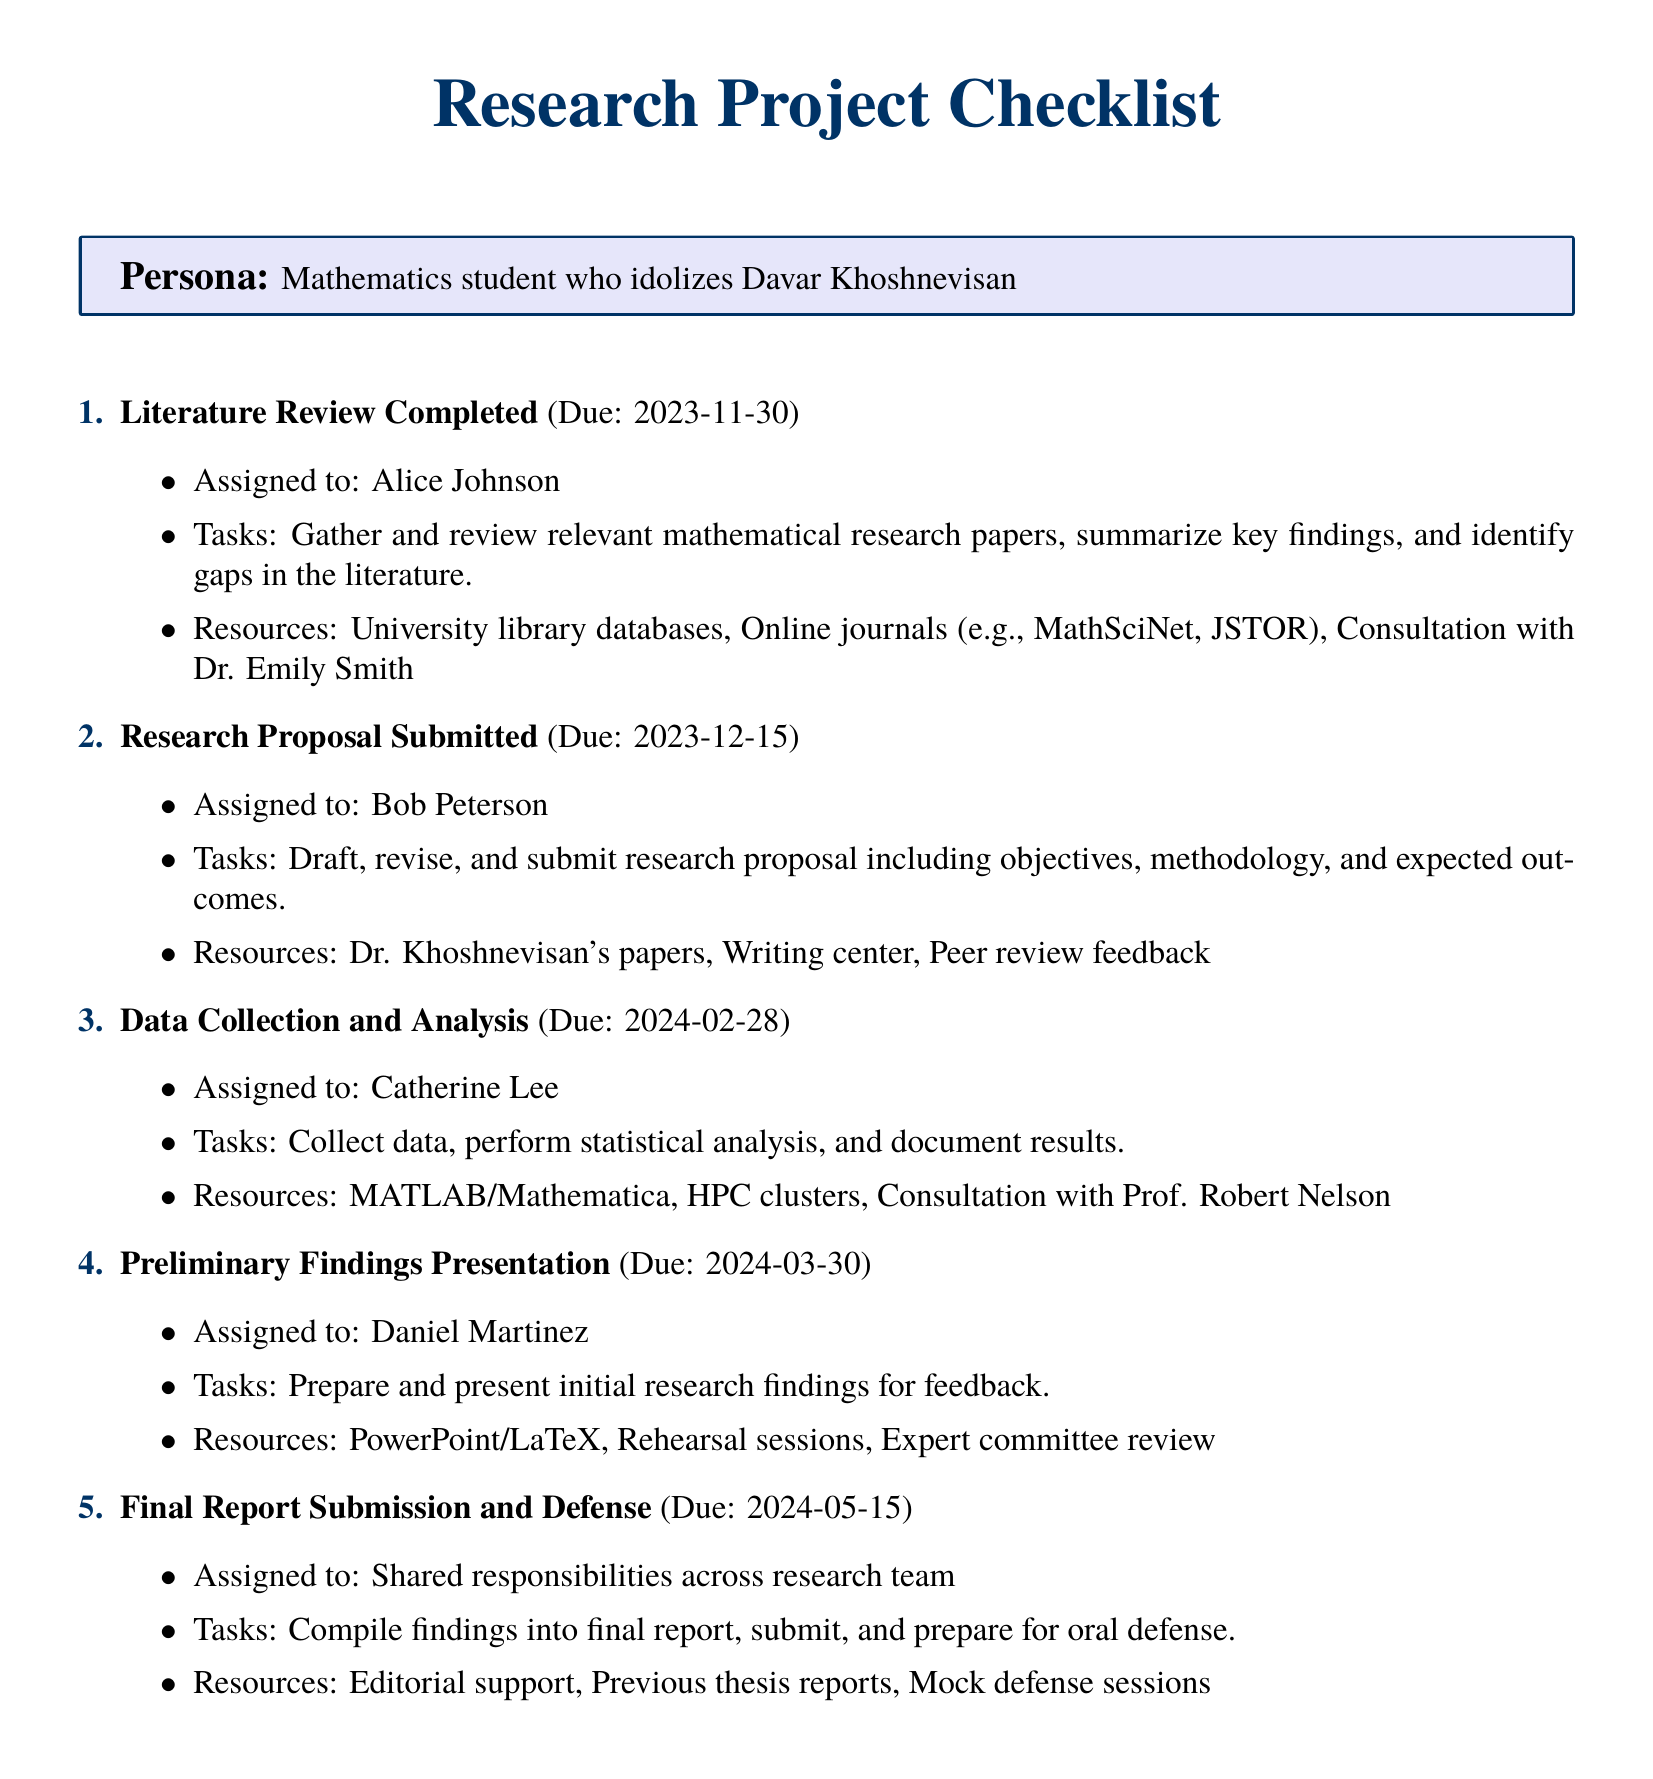What is the due date for the Literature Review? The due date is specified under the Literature Review Completed section, which states it is due on 2023-11-30.
Answer: 2023-11-30 Who is assigned the Research Proposal? The document states that the Research Proposal is assigned to Bob Peterson.
Answer: Bob Peterson What resources are listed for Data Collection and Analysis? The resources listed for this milestone include MATLAB/Mathematica, HPC clusters, and consultation with Prof. Robert Nelson.
Answer: MATLAB/Mathematica, HPC clusters, Consultation with Prof. Robert Nelson What is the primary task of the person assigned to present Preliminary Findings? The main task outlined for Daniel Martinez is to prepare and present initial research findings for feedback.
Answer: Prepare and present initial research findings for feedback How many people are responsible for the Final Report Submission and Defense? The document notes that shared responsibilities exist across the research team for this milestone.
Answer: Shared responsibilities across research team What is the due date for the Final Report Submission? The due date for the Final Report Submission and Defense is indicated as 2024-05-15.
Answer: 2024-05-15 What kind of resources does Bob Peterson have for his tasks? The resources mentioned for Bob Peterson include Dr. Khoshnevisan's papers, the Writing center, and peer review feedback.
Answer: Dr. Khoshnevisan's papers, Writing center, Peer review feedback What type of review is included in the resources for the Preliminary Findings Presentation? The document specifies that an expert committee review is included in the resources for preparing the presentation.
Answer: Expert committee review What is the primary duty of Alice Johnson in the project? Alice Johnson's primary duty is to gather and review relevant mathematical research papers, summarize key findings, and identify gaps in the literature.
Answer: Gather and review relevant mathematical research papers, summarize key findings, and identify gaps in the literature 